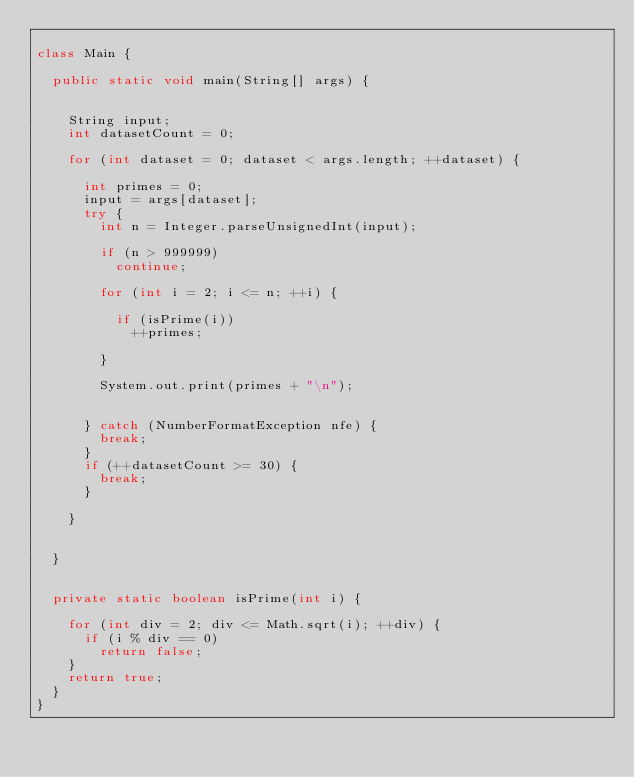<code> <loc_0><loc_0><loc_500><loc_500><_Java_>
class Main {
	
	public static void main(String[] args) {
	
		
		String input;
		int datasetCount = 0;
		
		for (int dataset = 0; dataset < args.length; ++dataset) {
			
			int primes = 0;
			input = args[dataset];
			try {
				int n = Integer.parseUnsignedInt(input);
				
				if (n > 999999)
					continue;
				
				for (int i = 2; i <= n; ++i) {
					
					if (isPrime(i))
						++primes;
					
				}
				
				System.out.print(primes + "\n");
				
				
			} catch (NumberFormatException nfe) {
				break;
			}
			if (++datasetCount >= 30) {
				break;
			}
			
		}
		
		
	}
	
	
	private static boolean isPrime(int i) {
	
		for (int div = 2; div <= Math.sqrt(i); ++div) {
			if (i % div == 0)
				return false;
		}
		return true;
	}
}</code> 